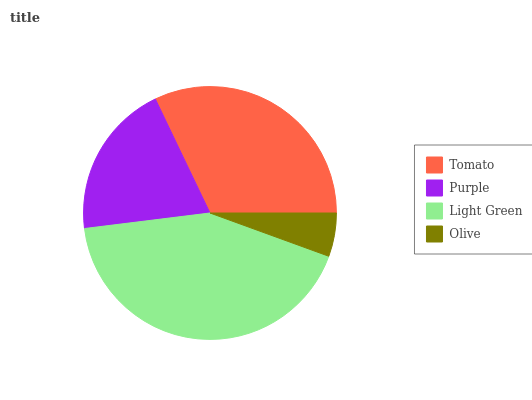Is Olive the minimum?
Answer yes or no. Yes. Is Light Green the maximum?
Answer yes or no. Yes. Is Purple the minimum?
Answer yes or no. No. Is Purple the maximum?
Answer yes or no. No. Is Tomato greater than Purple?
Answer yes or no. Yes. Is Purple less than Tomato?
Answer yes or no. Yes. Is Purple greater than Tomato?
Answer yes or no. No. Is Tomato less than Purple?
Answer yes or no. No. Is Tomato the high median?
Answer yes or no. Yes. Is Purple the low median?
Answer yes or no. Yes. Is Purple the high median?
Answer yes or no. No. Is Light Green the low median?
Answer yes or no. No. 